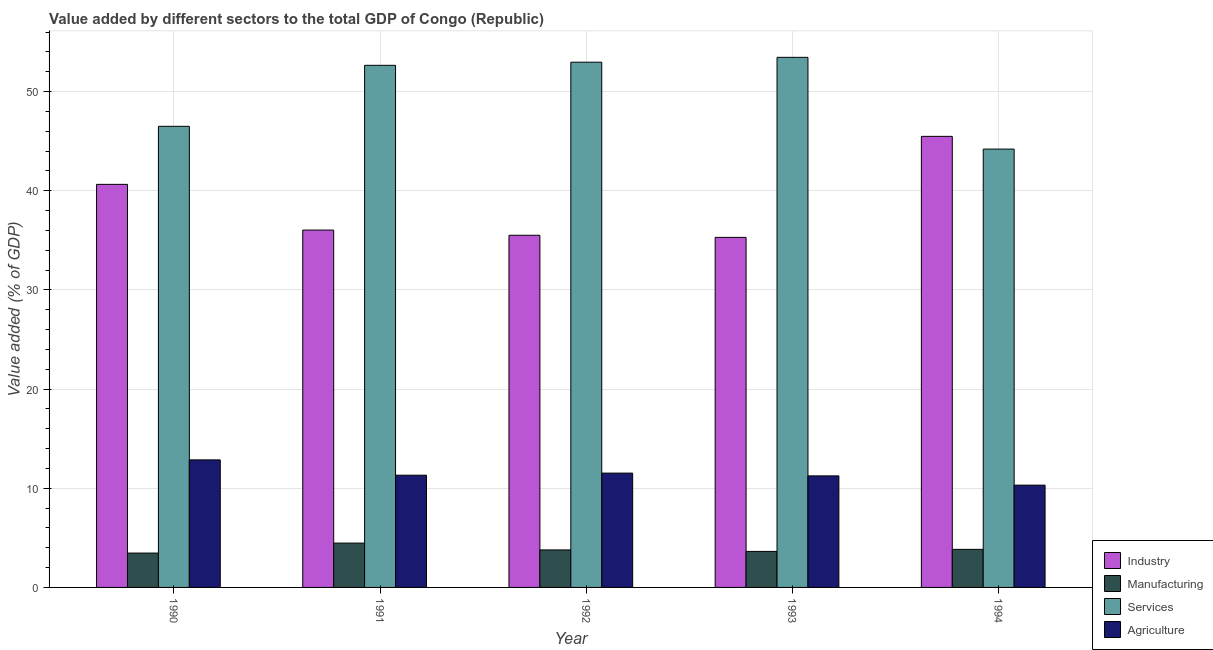How many different coloured bars are there?
Provide a succinct answer. 4. How many groups of bars are there?
Keep it short and to the point. 5. What is the value added by industrial sector in 1991?
Ensure brevity in your answer.  36.03. Across all years, what is the maximum value added by services sector?
Make the answer very short. 53.45. Across all years, what is the minimum value added by services sector?
Make the answer very short. 44.2. In which year was the value added by manufacturing sector maximum?
Provide a succinct answer. 1991. In which year was the value added by industrial sector minimum?
Your answer should be very brief. 1993. What is the total value added by manufacturing sector in the graph?
Your answer should be compact. 19.19. What is the difference between the value added by manufacturing sector in 1991 and that in 1994?
Your response must be concise. 0.63. What is the difference between the value added by agricultural sector in 1991 and the value added by industrial sector in 1994?
Give a very brief answer. 1. What is the average value added by services sector per year?
Your answer should be very brief. 49.95. In the year 1992, what is the difference between the value added by agricultural sector and value added by manufacturing sector?
Provide a short and direct response. 0. What is the ratio of the value added by industrial sector in 1990 to that in 1993?
Offer a very short reply. 1.15. Is the value added by manufacturing sector in 1990 less than that in 1994?
Your response must be concise. Yes. Is the difference between the value added by manufacturing sector in 1990 and 1993 greater than the difference between the value added by services sector in 1990 and 1993?
Your answer should be compact. No. What is the difference between the highest and the second highest value added by industrial sector?
Offer a very short reply. 4.84. What is the difference between the highest and the lowest value added by manufacturing sector?
Your answer should be compact. 1.01. In how many years, is the value added by manufacturing sector greater than the average value added by manufacturing sector taken over all years?
Make the answer very short. 2. What does the 3rd bar from the left in 1994 represents?
Your answer should be compact. Services. What does the 4th bar from the right in 1992 represents?
Provide a succinct answer. Industry. Is it the case that in every year, the sum of the value added by industrial sector and value added by manufacturing sector is greater than the value added by services sector?
Make the answer very short. No. How many bars are there?
Give a very brief answer. 20. Are all the bars in the graph horizontal?
Offer a terse response. No. How many years are there in the graph?
Offer a terse response. 5. What is the difference between two consecutive major ticks on the Y-axis?
Your response must be concise. 10. Are the values on the major ticks of Y-axis written in scientific E-notation?
Provide a short and direct response. No. Does the graph contain grids?
Provide a short and direct response. Yes. Where does the legend appear in the graph?
Your answer should be very brief. Bottom right. How many legend labels are there?
Give a very brief answer. 4. How are the legend labels stacked?
Your response must be concise. Vertical. What is the title of the graph?
Make the answer very short. Value added by different sectors to the total GDP of Congo (Republic). Does "Austria" appear as one of the legend labels in the graph?
Your answer should be very brief. No. What is the label or title of the Y-axis?
Give a very brief answer. Value added (% of GDP). What is the Value added (% of GDP) of Industry in 1990?
Make the answer very short. 40.64. What is the Value added (% of GDP) in Manufacturing in 1990?
Give a very brief answer. 3.46. What is the Value added (% of GDP) of Services in 1990?
Make the answer very short. 46.5. What is the Value added (% of GDP) in Agriculture in 1990?
Your response must be concise. 12.86. What is the Value added (% of GDP) in Industry in 1991?
Your answer should be compact. 36.03. What is the Value added (% of GDP) of Manufacturing in 1991?
Your response must be concise. 4.47. What is the Value added (% of GDP) of Services in 1991?
Make the answer very short. 52.65. What is the Value added (% of GDP) in Agriculture in 1991?
Provide a succinct answer. 11.32. What is the Value added (% of GDP) in Industry in 1992?
Offer a very short reply. 35.51. What is the Value added (% of GDP) in Manufacturing in 1992?
Your response must be concise. 3.78. What is the Value added (% of GDP) of Services in 1992?
Make the answer very short. 52.96. What is the Value added (% of GDP) of Agriculture in 1992?
Ensure brevity in your answer.  11.53. What is the Value added (% of GDP) of Industry in 1993?
Keep it short and to the point. 35.3. What is the Value added (% of GDP) of Manufacturing in 1993?
Make the answer very short. 3.63. What is the Value added (% of GDP) of Services in 1993?
Ensure brevity in your answer.  53.45. What is the Value added (% of GDP) in Agriculture in 1993?
Your response must be concise. 11.25. What is the Value added (% of GDP) of Industry in 1994?
Ensure brevity in your answer.  45.48. What is the Value added (% of GDP) of Manufacturing in 1994?
Provide a short and direct response. 3.84. What is the Value added (% of GDP) of Services in 1994?
Provide a short and direct response. 44.2. What is the Value added (% of GDP) in Agriculture in 1994?
Ensure brevity in your answer.  10.31. Across all years, what is the maximum Value added (% of GDP) of Industry?
Make the answer very short. 45.48. Across all years, what is the maximum Value added (% of GDP) of Manufacturing?
Provide a short and direct response. 4.47. Across all years, what is the maximum Value added (% of GDP) in Services?
Give a very brief answer. 53.45. Across all years, what is the maximum Value added (% of GDP) in Agriculture?
Make the answer very short. 12.86. Across all years, what is the minimum Value added (% of GDP) of Industry?
Your answer should be compact. 35.3. Across all years, what is the minimum Value added (% of GDP) in Manufacturing?
Your response must be concise. 3.46. Across all years, what is the minimum Value added (% of GDP) of Services?
Your response must be concise. 44.2. Across all years, what is the minimum Value added (% of GDP) in Agriculture?
Your answer should be compact. 10.31. What is the total Value added (% of GDP) in Industry in the graph?
Offer a terse response. 192.97. What is the total Value added (% of GDP) of Manufacturing in the graph?
Give a very brief answer. 19.19. What is the total Value added (% of GDP) of Services in the graph?
Provide a short and direct response. 249.76. What is the total Value added (% of GDP) of Agriculture in the graph?
Your response must be concise. 57.27. What is the difference between the Value added (% of GDP) in Industry in 1990 and that in 1991?
Keep it short and to the point. 4.61. What is the difference between the Value added (% of GDP) of Manufacturing in 1990 and that in 1991?
Offer a terse response. -1.01. What is the difference between the Value added (% of GDP) of Services in 1990 and that in 1991?
Ensure brevity in your answer.  -6.15. What is the difference between the Value added (% of GDP) in Agriculture in 1990 and that in 1991?
Provide a succinct answer. 1.54. What is the difference between the Value added (% of GDP) in Industry in 1990 and that in 1992?
Offer a terse response. 5.13. What is the difference between the Value added (% of GDP) in Manufacturing in 1990 and that in 1992?
Make the answer very short. -0.32. What is the difference between the Value added (% of GDP) of Services in 1990 and that in 1992?
Your answer should be very brief. -6.47. What is the difference between the Value added (% of GDP) in Industry in 1990 and that in 1993?
Provide a short and direct response. 5.35. What is the difference between the Value added (% of GDP) in Manufacturing in 1990 and that in 1993?
Keep it short and to the point. -0.17. What is the difference between the Value added (% of GDP) in Services in 1990 and that in 1993?
Provide a succinct answer. -6.96. What is the difference between the Value added (% of GDP) of Agriculture in 1990 and that in 1993?
Provide a short and direct response. 1.61. What is the difference between the Value added (% of GDP) in Industry in 1990 and that in 1994?
Make the answer very short. -4.84. What is the difference between the Value added (% of GDP) of Manufacturing in 1990 and that in 1994?
Your response must be concise. -0.37. What is the difference between the Value added (% of GDP) in Services in 1990 and that in 1994?
Give a very brief answer. 2.29. What is the difference between the Value added (% of GDP) in Agriculture in 1990 and that in 1994?
Make the answer very short. 2.55. What is the difference between the Value added (% of GDP) in Industry in 1991 and that in 1992?
Make the answer very short. 0.52. What is the difference between the Value added (% of GDP) in Manufacturing in 1991 and that in 1992?
Your response must be concise. 0.69. What is the difference between the Value added (% of GDP) in Services in 1991 and that in 1992?
Your answer should be very brief. -0.32. What is the difference between the Value added (% of GDP) of Agriculture in 1991 and that in 1992?
Offer a terse response. -0.21. What is the difference between the Value added (% of GDP) in Industry in 1991 and that in 1993?
Make the answer very short. 0.74. What is the difference between the Value added (% of GDP) of Manufacturing in 1991 and that in 1993?
Provide a succinct answer. 0.84. What is the difference between the Value added (% of GDP) of Services in 1991 and that in 1993?
Provide a succinct answer. -0.81. What is the difference between the Value added (% of GDP) in Agriculture in 1991 and that in 1993?
Your answer should be very brief. 0.07. What is the difference between the Value added (% of GDP) of Industry in 1991 and that in 1994?
Make the answer very short. -9.45. What is the difference between the Value added (% of GDP) of Manufacturing in 1991 and that in 1994?
Offer a terse response. 0.63. What is the difference between the Value added (% of GDP) in Services in 1991 and that in 1994?
Your response must be concise. 8.45. What is the difference between the Value added (% of GDP) in Industry in 1992 and that in 1993?
Provide a succinct answer. 0.21. What is the difference between the Value added (% of GDP) of Manufacturing in 1992 and that in 1993?
Provide a succinct answer. 0.15. What is the difference between the Value added (% of GDP) of Services in 1992 and that in 1993?
Your answer should be very brief. -0.49. What is the difference between the Value added (% of GDP) of Agriculture in 1992 and that in 1993?
Offer a terse response. 0.28. What is the difference between the Value added (% of GDP) in Industry in 1992 and that in 1994?
Your response must be concise. -9.97. What is the difference between the Value added (% of GDP) in Manufacturing in 1992 and that in 1994?
Offer a terse response. -0.06. What is the difference between the Value added (% of GDP) in Services in 1992 and that in 1994?
Provide a succinct answer. 8.76. What is the difference between the Value added (% of GDP) in Agriculture in 1992 and that in 1994?
Your answer should be compact. 1.21. What is the difference between the Value added (% of GDP) of Industry in 1993 and that in 1994?
Ensure brevity in your answer.  -10.19. What is the difference between the Value added (% of GDP) in Manufacturing in 1993 and that in 1994?
Ensure brevity in your answer.  -0.21. What is the difference between the Value added (% of GDP) in Services in 1993 and that in 1994?
Offer a terse response. 9.25. What is the difference between the Value added (% of GDP) in Agriculture in 1993 and that in 1994?
Provide a succinct answer. 0.93. What is the difference between the Value added (% of GDP) in Industry in 1990 and the Value added (% of GDP) in Manufacturing in 1991?
Make the answer very short. 36.17. What is the difference between the Value added (% of GDP) in Industry in 1990 and the Value added (% of GDP) in Services in 1991?
Offer a terse response. -12. What is the difference between the Value added (% of GDP) of Industry in 1990 and the Value added (% of GDP) of Agriculture in 1991?
Offer a very short reply. 29.33. What is the difference between the Value added (% of GDP) of Manufacturing in 1990 and the Value added (% of GDP) of Services in 1991?
Your answer should be very brief. -49.18. What is the difference between the Value added (% of GDP) of Manufacturing in 1990 and the Value added (% of GDP) of Agriculture in 1991?
Keep it short and to the point. -7.85. What is the difference between the Value added (% of GDP) in Services in 1990 and the Value added (% of GDP) in Agriculture in 1991?
Keep it short and to the point. 35.18. What is the difference between the Value added (% of GDP) of Industry in 1990 and the Value added (% of GDP) of Manufacturing in 1992?
Your response must be concise. 36.86. What is the difference between the Value added (% of GDP) of Industry in 1990 and the Value added (% of GDP) of Services in 1992?
Make the answer very short. -12.32. What is the difference between the Value added (% of GDP) in Industry in 1990 and the Value added (% of GDP) in Agriculture in 1992?
Your response must be concise. 29.12. What is the difference between the Value added (% of GDP) in Manufacturing in 1990 and the Value added (% of GDP) in Services in 1992?
Your answer should be very brief. -49.5. What is the difference between the Value added (% of GDP) of Manufacturing in 1990 and the Value added (% of GDP) of Agriculture in 1992?
Make the answer very short. -8.06. What is the difference between the Value added (% of GDP) of Services in 1990 and the Value added (% of GDP) of Agriculture in 1992?
Make the answer very short. 34.97. What is the difference between the Value added (% of GDP) in Industry in 1990 and the Value added (% of GDP) in Manufacturing in 1993?
Keep it short and to the point. 37.01. What is the difference between the Value added (% of GDP) of Industry in 1990 and the Value added (% of GDP) of Services in 1993?
Your answer should be very brief. -12.81. What is the difference between the Value added (% of GDP) in Industry in 1990 and the Value added (% of GDP) in Agriculture in 1993?
Your answer should be compact. 29.39. What is the difference between the Value added (% of GDP) of Manufacturing in 1990 and the Value added (% of GDP) of Services in 1993?
Provide a succinct answer. -49.99. What is the difference between the Value added (% of GDP) in Manufacturing in 1990 and the Value added (% of GDP) in Agriculture in 1993?
Your answer should be compact. -7.78. What is the difference between the Value added (% of GDP) in Services in 1990 and the Value added (% of GDP) in Agriculture in 1993?
Give a very brief answer. 35.25. What is the difference between the Value added (% of GDP) of Industry in 1990 and the Value added (% of GDP) of Manufacturing in 1994?
Offer a very short reply. 36.8. What is the difference between the Value added (% of GDP) in Industry in 1990 and the Value added (% of GDP) in Services in 1994?
Ensure brevity in your answer.  -3.56. What is the difference between the Value added (% of GDP) of Industry in 1990 and the Value added (% of GDP) of Agriculture in 1994?
Provide a succinct answer. 30.33. What is the difference between the Value added (% of GDP) of Manufacturing in 1990 and the Value added (% of GDP) of Services in 1994?
Your answer should be compact. -40.74. What is the difference between the Value added (% of GDP) of Manufacturing in 1990 and the Value added (% of GDP) of Agriculture in 1994?
Provide a succinct answer. -6.85. What is the difference between the Value added (% of GDP) in Services in 1990 and the Value added (% of GDP) in Agriculture in 1994?
Give a very brief answer. 36.18. What is the difference between the Value added (% of GDP) in Industry in 1991 and the Value added (% of GDP) in Manufacturing in 1992?
Your answer should be compact. 32.25. What is the difference between the Value added (% of GDP) of Industry in 1991 and the Value added (% of GDP) of Services in 1992?
Provide a succinct answer. -16.93. What is the difference between the Value added (% of GDP) of Industry in 1991 and the Value added (% of GDP) of Agriculture in 1992?
Give a very brief answer. 24.51. What is the difference between the Value added (% of GDP) of Manufacturing in 1991 and the Value added (% of GDP) of Services in 1992?
Provide a short and direct response. -48.49. What is the difference between the Value added (% of GDP) of Manufacturing in 1991 and the Value added (% of GDP) of Agriculture in 1992?
Provide a short and direct response. -7.06. What is the difference between the Value added (% of GDP) in Services in 1991 and the Value added (% of GDP) in Agriculture in 1992?
Provide a short and direct response. 41.12. What is the difference between the Value added (% of GDP) in Industry in 1991 and the Value added (% of GDP) in Manufacturing in 1993?
Ensure brevity in your answer.  32.4. What is the difference between the Value added (% of GDP) of Industry in 1991 and the Value added (% of GDP) of Services in 1993?
Provide a short and direct response. -17.42. What is the difference between the Value added (% of GDP) in Industry in 1991 and the Value added (% of GDP) in Agriculture in 1993?
Ensure brevity in your answer.  24.79. What is the difference between the Value added (% of GDP) of Manufacturing in 1991 and the Value added (% of GDP) of Services in 1993?
Give a very brief answer. -48.98. What is the difference between the Value added (% of GDP) of Manufacturing in 1991 and the Value added (% of GDP) of Agriculture in 1993?
Offer a very short reply. -6.78. What is the difference between the Value added (% of GDP) of Services in 1991 and the Value added (% of GDP) of Agriculture in 1993?
Provide a succinct answer. 41.4. What is the difference between the Value added (% of GDP) in Industry in 1991 and the Value added (% of GDP) in Manufacturing in 1994?
Your answer should be very brief. 32.2. What is the difference between the Value added (% of GDP) of Industry in 1991 and the Value added (% of GDP) of Services in 1994?
Offer a very short reply. -8.17. What is the difference between the Value added (% of GDP) of Industry in 1991 and the Value added (% of GDP) of Agriculture in 1994?
Provide a succinct answer. 25.72. What is the difference between the Value added (% of GDP) in Manufacturing in 1991 and the Value added (% of GDP) in Services in 1994?
Offer a very short reply. -39.73. What is the difference between the Value added (% of GDP) in Manufacturing in 1991 and the Value added (% of GDP) in Agriculture in 1994?
Ensure brevity in your answer.  -5.84. What is the difference between the Value added (% of GDP) in Services in 1991 and the Value added (% of GDP) in Agriculture in 1994?
Your answer should be compact. 42.33. What is the difference between the Value added (% of GDP) in Industry in 1992 and the Value added (% of GDP) in Manufacturing in 1993?
Keep it short and to the point. 31.88. What is the difference between the Value added (% of GDP) in Industry in 1992 and the Value added (% of GDP) in Services in 1993?
Your answer should be compact. -17.94. What is the difference between the Value added (% of GDP) in Industry in 1992 and the Value added (% of GDP) in Agriculture in 1993?
Ensure brevity in your answer.  24.26. What is the difference between the Value added (% of GDP) in Manufacturing in 1992 and the Value added (% of GDP) in Services in 1993?
Your response must be concise. -49.67. What is the difference between the Value added (% of GDP) of Manufacturing in 1992 and the Value added (% of GDP) of Agriculture in 1993?
Offer a very short reply. -7.47. What is the difference between the Value added (% of GDP) of Services in 1992 and the Value added (% of GDP) of Agriculture in 1993?
Offer a very short reply. 41.71. What is the difference between the Value added (% of GDP) of Industry in 1992 and the Value added (% of GDP) of Manufacturing in 1994?
Provide a succinct answer. 31.67. What is the difference between the Value added (% of GDP) of Industry in 1992 and the Value added (% of GDP) of Services in 1994?
Give a very brief answer. -8.69. What is the difference between the Value added (% of GDP) in Industry in 1992 and the Value added (% of GDP) in Agriculture in 1994?
Make the answer very short. 25.2. What is the difference between the Value added (% of GDP) of Manufacturing in 1992 and the Value added (% of GDP) of Services in 1994?
Keep it short and to the point. -40.42. What is the difference between the Value added (% of GDP) in Manufacturing in 1992 and the Value added (% of GDP) in Agriculture in 1994?
Offer a very short reply. -6.53. What is the difference between the Value added (% of GDP) of Services in 1992 and the Value added (% of GDP) of Agriculture in 1994?
Your answer should be very brief. 42.65. What is the difference between the Value added (% of GDP) of Industry in 1993 and the Value added (% of GDP) of Manufacturing in 1994?
Provide a succinct answer. 31.46. What is the difference between the Value added (% of GDP) in Industry in 1993 and the Value added (% of GDP) in Services in 1994?
Your response must be concise. -8.9. What is the difference between the Value added (% of GDP) of Industry in 1993 and the Value added (% of GDP) of Agriculture in 1994?
Your response must be concise. 24.98. What is the difference between the Value added (% of GDP) in Manufacturing in 1993 and the Value added (% of GDP) in Services in 1994?
Make the answer very short. -40.57. What is the difference between the Value added (% of GDP) of Manufacturing in 1993 and the Value added (% of GDP) of Agriculture in 1994?
Offer a very short reply. -6.68. What is the difference between the Value added (% of GDP) in Services in 1993 and the Value added (% of GDP) in Agriculture in 1994?
Ensure brevity in your answer.  43.14. What is the average Value added (% of GDP) in Industry per year?
Your response must be concise. 38.59. What is the average Value added (% of GDP) in Manufacturing per year?
Give a very brief answer. 3.84. What is the average Value added (% of GDP) of Services per year?
Offer a terse response. 49.95. What is the average Value added (% of GDP) in Agriculture per year?
Your answer should be compact. 11.45. In the year 1990, what is the difference between the Value added (% of GDP) of Industry and Value added (% of GDP) of Manufacturing?
Your response must be concise. 37.18. In the year 1990, what is the difference between the Value added (% of GDP) in Industry and Value added (% of GDP) in Services?
Offer a terse response. -5.85. In the year 1990, what is the difference between the Value added (% of GDP) of Industry and Value added (% of GDP) of Agriculture?
Your response must be concise. 27.78. In the year 1990, what is the difference between the Value added (% of GDP) in Manufacturing and Value added (% of GDP) in Services?
Your answer should be compact. -43.03. In the year 1990, what is the difference between the Value added (% of GDP) of Manufacturing and Value added (% of GDP) of Agriculture?
Make the answer very short. -9.4. In the year 1990, what is the difference between the Value added (% of GDP) in Services and Value added (% of GDP) in Agriculture?
Offer a terse response. 33.64. In the year 1991, what is the difference between the Value added (% of GDP) in Industry and Value added (% of GDP) in Manufacturing?
Your response must be concise. 31.56. In the year 1991, what is the difference between the Value added (% of GDP) in Industry and Value added (% of GDP) in Services?
Your response must be concise. -16.61. In the year 1991, what is the difference between the Value added (% of GDP) of Industry and Value added (% of GDP) of Agriculture?
Offer a very short reply. 24.72. In the year 1991, what is the difference between the Value added (% of GDP) in Manufacturing and Value added (% of GDP) in Services?
Ensure brevity in your answer.  -48.18. In the year 1991, what is the difference between the Value added (% of GDP) in Manufacturing and Value added (% of GDP) in Agriculture?
Keep it short and to the point. -6.85. In the year 1991, what is the difference between the Value added (% of GDP) in Services and Value added (% of GDP) in Agriculture?
Keep it short and to the point. 41.33. In the year 1992, what is the difference between the Value added (% of GDP) of Industry and Value added (% of GDP) of Manufacturing?
Keep it short and to the point. 31.73. In the year 1992, what is the difference between the Value added (% of GDP) of Industry and Value added (% of GDP) of Services?
Your response must be concise. -17.45. In the year 1992, what is the difference between the Value added (% of GDP) in Industry and Value added (% of GDP) in Agriculture?
Provide a succinct answer. 23.98. In the year 1992, what is the difference between the Value added (% of GDP) of Manufacturing and Value added (% of GDP) of Services?
Make the answer very short. -49.18. In the year 1992, what is the difference between the Value added (% of GDP) of Manufacturing and Value added (% of GDP) of Agriculture?
Ensure brevity in your answer.  -7.74. In the year 1992, what is the difference between the Value added (% of GDP) in Services and Value added (% of GDP) in Agriculture?
Ensure brevity in your answer.  41.43. In the year 1993, what is the difference between the Value added (% of GDP) in Industry and Value added (% of GDP) in Manufacturing?
Your answer should be compact. 31.67. In the year 1993, what is the difference between the Value added (% of GDP) of Industry and Value added (% of GDP) of Services?
Give a very brief answer. -18.16. In the year 1993, what is the difference between the Value added (% of GDP) of Industry and Value added (% of GDP) of Agriculture?
Provide a short and direct response. 24.05. In the year 1993, what is the difference between the Value added (% of GDP) in Manufacturing and Value added (% of GDP) in Services?
Give a very brief answer. -49.82. In the year 1993, what is the difference between the Value added (% of GDP) of Manufacturing and Value added (% of GDP) of Agriculture?
Provide a succinct answer. -7.62. In the year 1993, what is the difference between the Value added (% of GDP) of Services and Value added (% of GDP) of Agriculture?
Offer a very short reply. 42.2. In the year 1994, what is the difference between the Value added (% of GDP) of Industry and Value added (% of GDP) of Manufacturing?
Your response must be concise. 41.65. In the year 1994, what is the difference between the Value added (% of GDP) of Industry and Value added (% of GDP) of Services?
Your answer should be compact. 1.28. In the year 1994, what is the difference between the Value added (% of GDP) of Industry and Value added (% of GDP) of Agriculture?
Offer a very short reply. 35.17. In the year 1994, what is the difference between the Value added (% of GDP) in Manufacturing and Value added (% of GDP) in Services?
Make the answer very short. -40.36. In the year 1994, what is the difference between the Value added (% of GDP) in Manufacturing and Value added (% of GDP) in Agriculture?
Your response must be concise. -6.48. In the year 1994, what is the difference between the Value added (% of GDP) of Services and Value added (% of GDP) of Agriculture?
Make the answer very short. 33.89. What is the ratio of the Value added (% of GDP) in Industry in 1990 to that in 1991?
Make the answer very short. 1.13. What is the ratio of the Value added (% of GDP) in Manufacturing in 1990 to that in 1991?
Offer a very short reply. 0.77. What is the ratio of the Value added (% of GDP) in Services in 1990 to that in 1991?
Give a very brief answer. 0.88. What is the ratio of the Value added (% of GDP) in Agriculture in 1990 to that in 1991?
Give a very brief answer. 1.14. What is the ratio of the Value added (% of GDP) of Industry in 1990 to that in 1992?
Provide a succinct answer. 1.14. What is the ratio of the Value added (% of GDP) in Manufacturing in 1990 to that in 1992?
Your answer should be compact. 0.92. What is the ratio of the Value added (% of GDP) in Services in 1990 to that in 1992?
Keep it short and to the point. 0.88. What is the ratio of the Value added (% of GDP) in Agriculture in 1990 to that in 1992?
Your answer should be compact. 1.12. What is the ratio of the Value added (% of GDP) of Industry in 1990 to that in 1993?
Your answer should be very brief. 1.15. What is the ratio of the Value added (% of GDP) of Manufacturing in 1990 to that in 1993?
Ensure brevity in your answer.  0.95. What is the ratio of the Value added (% of GDP) in Services in 1990 to that in 1993?
Offer a very short reply. 0.87. What is the ratio of the Value added (% of GDP) in Agriculture in 1990 to that in 1993?
Your answer should be very brief. 1.14. What is the ratio of the Value added (% of GDP) of Industry in 1990 to that in 1994?
Give a very brief answer. 0.89. What is the ratio of the Value added (% of GDP) of Manufacturing in 1990 to that in 1994?
Offer a terse response. 0.9. What is the ratio of the Value added (% of GDP) in Services in 1990 to that in 1994?
Your answer should be very brief. 1.05. What is the ratio of the Value added (% of GDP) in Agriculture in 1990 to that in 1994?
Give a very brief answer. 1.25. What is the ratio of the Value added (% of GDP) in Industry in 1991 to that in 1992?
Ensure brevity in your answer.  1.01. What is the ratio of the Value added (% of GDP) in Manufacturing in 1991 to that in 1992?
Your answer should be very brief. 1.18. What is the ratio of the Value added (% of GDP) in Agriculture in 1991 to that in 1992?
Ensure brevity in your answer.  0.98. What is the ratio of the Value added (% of GDP) in Industry in 1991 to that in 1993?
Keep it short and to the point. 1.02. What is the ratio of the Value added (% of GDP) of Manufacturing in 1991 to that in 1993?
Provide a short and direct response. 1.23. What is the ratio of the Value added (% of GDP) in Services in 1991 to that in 1993?
Your answer should be very brief. 0.98. What is the ratio of the Value added (% of GDP) of Industry in 1991 to that in 1994?
Ensure brevity in your answer.  0.79. What is the ratio of the Value added (% of GDP) in Manufacturing in 1991 to that in 1994?
Give a very brief answer. 1.16. What is the ratio of the Value added (% of GDP) in Services in 1991 to that in 1994?
Ensure brevity in your answer.  1.19. What is the ratio of the Value added (% of GDP) in Agriculture in 1991 to that in 1994?
Give a very brief answer. 1.1. What is the ratio of the Value added (% of GDP) of Manufacturing in 1992 to that in 1993?
Provide a succinct answer. 1.04. What is the ratio of the Value added (% of GDP) in Services in 1992 to that in 1993?
Provide a succinct answer. 0.99. What is the ratio of the Value added (% of GDP) in Agriculture in 1992 to that in 1993?
Ensure brevity in your answer.  1.02. What is the ratio of the Value added (% of GDP) in Industry in 1992 to that in 1994?
Keep it short and to the point. 0.78. What is the ratio of the Value added (% of GDP) in Manufacturing in 1992 to that in 1994?
Give a very brief answer. 0.99. What is the ratio of the Value added (% of GDP) of Services in 1992 to that in 1994?
Provide a short and direct response. 1.2. What is the ratio of the Value added (% of GDP) in Agriculture in 1992 to that in 1994?
Provide a succinct answer. 1.12. What is the ratio of the Value added (% of GDP) of Industry in 1993 to that in 1994?
Provide a short and direct response. 0.78. What is the ratio of the Value added (% of GDP) in Manufacturing in 1993 to that in 1994?
Provide a succinct answer. 0.95. What is the ratio of the Value added (% of GDP) of Services in 1993 to that in 1994?
Your response must be concise. 1.21. What is the ratio of the Value added (% of GDP) of Agriculture in 1993 to that in 1994?
Keep it short and to the point. 1.09. What is the difference between the highest and the second highest Value added (% of GDP) of Industry?
Ensure brevity in your answer.  4.84. What is the difference between the highest and the second highest Value added (% of GDP) of Manufacturing?
Your answer should be compact. 0.63. What is the difference between the highest and the second highest Value added (% of GDP) in Services?
Ensure brevity in your answer.  0.49. What is the difference between the highest and the lowest Value added (% of GDP) in Industry?
Provide a short and direct response. 10.19. What is the difference between the highest and the lowest Value added (% of GDP) of Manufacturing?
Your answer should be very brief. 1.01. What is the difference between the highest and the lowest Value added (% of GDP) in Services?
Offer a terse response. 9.25. What is the difference between the highest and the lowest Value added (% of GDP) in Agriculture?
Your answer should be very brief. 2.55. 